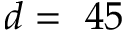<formula> <loc_0><loc_0><loc_500><loc_500>d = 4 5</formula> 